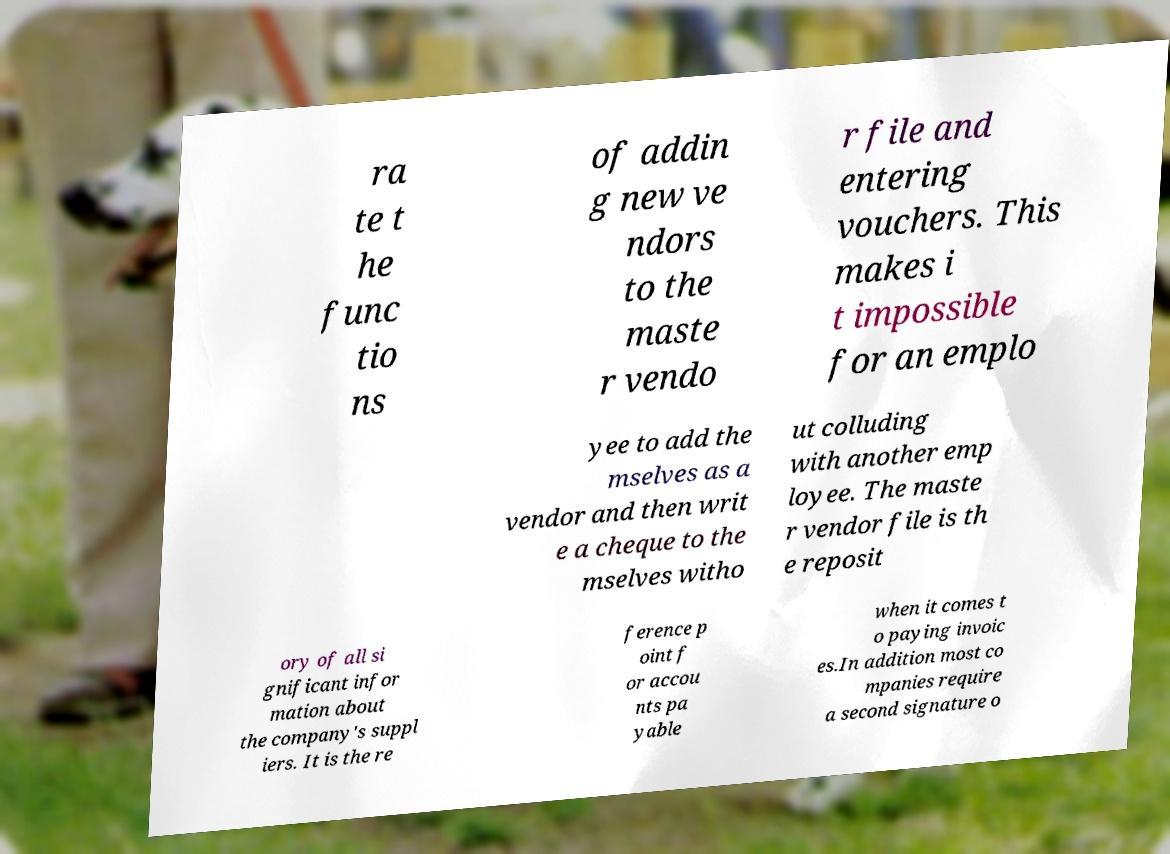Could you extract and type out the text from this image? ra te t he func tio ns of addin g new ve ndors to the maste r vendo r file and entering vouchers. This makes i t impossible for an emplo yee to add the mselves as a vendor and then writ e a cheque to the mselves witho ut colluding with another emp loyee. The maste r vendor file is th e reposit ory of all si gnificant infor mation about the company's suppl iers. It is the re ference p oint f or accou nts pa yable when it comes t o paying invoic es.In addition most co mpanies require a second signature o 